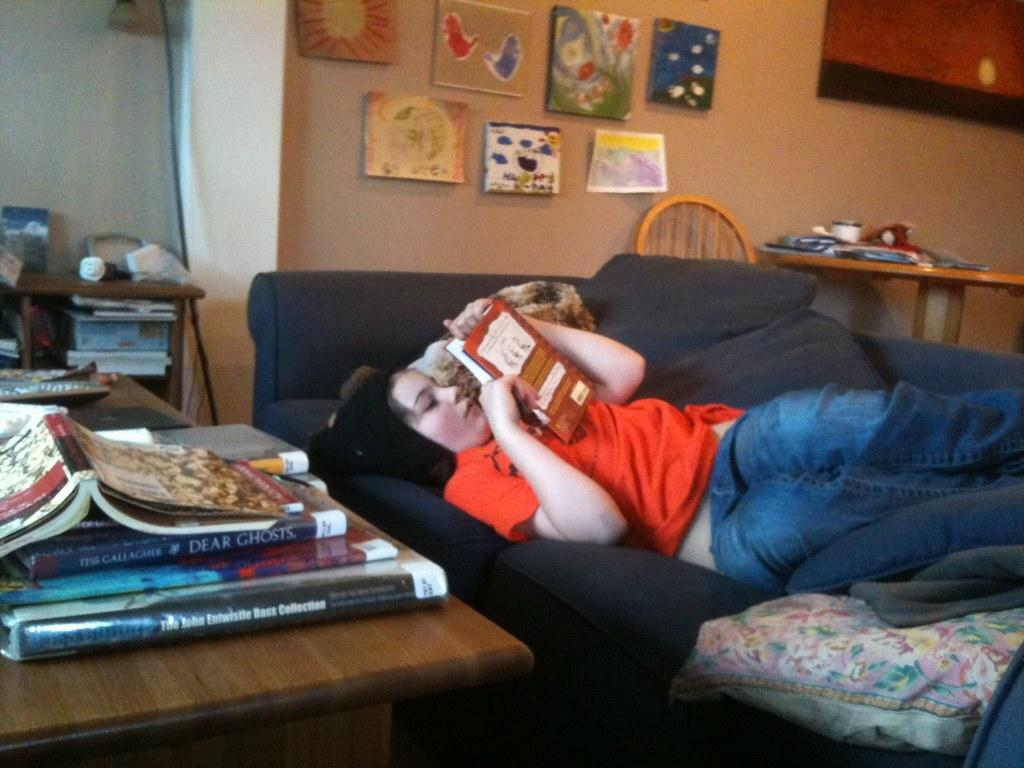<image>
Offer a succinct explanation of the picture presented. a person lounged out on a couch with a book and other books like Dear Ghosts on the table near them 